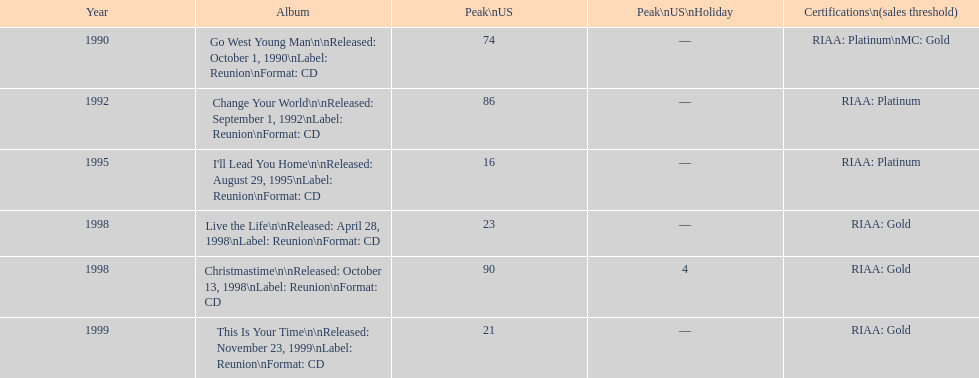What year is the oldest one on the list? 1990. 